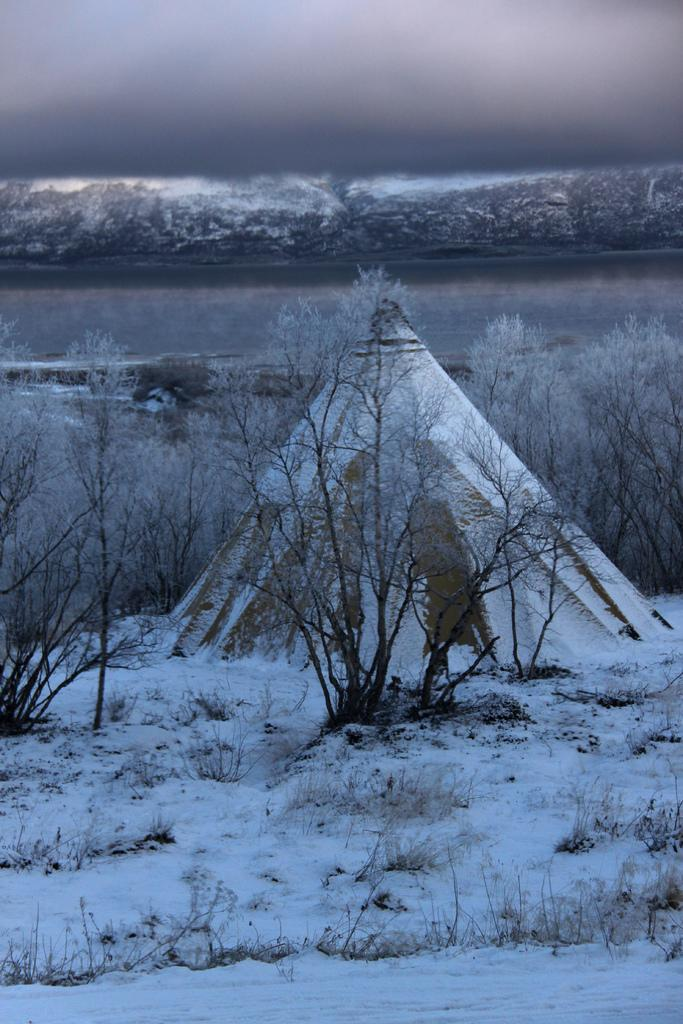What type of vegetation can be seen in the image? There are trees in the image. What is covering the ground in the image? There is grass on the ground in the image. What is the weather like in the image? The sky appears to be cloudy in the image. What natural elements can be seen in the image? There is snow and water visible in the image. What type of instrument is being played in the image? There is no instrument present in the image; it features trees, grass, snow, water, and a cloudy sky. What are the chances of finding glue in the image? There is no glue present in the image. 